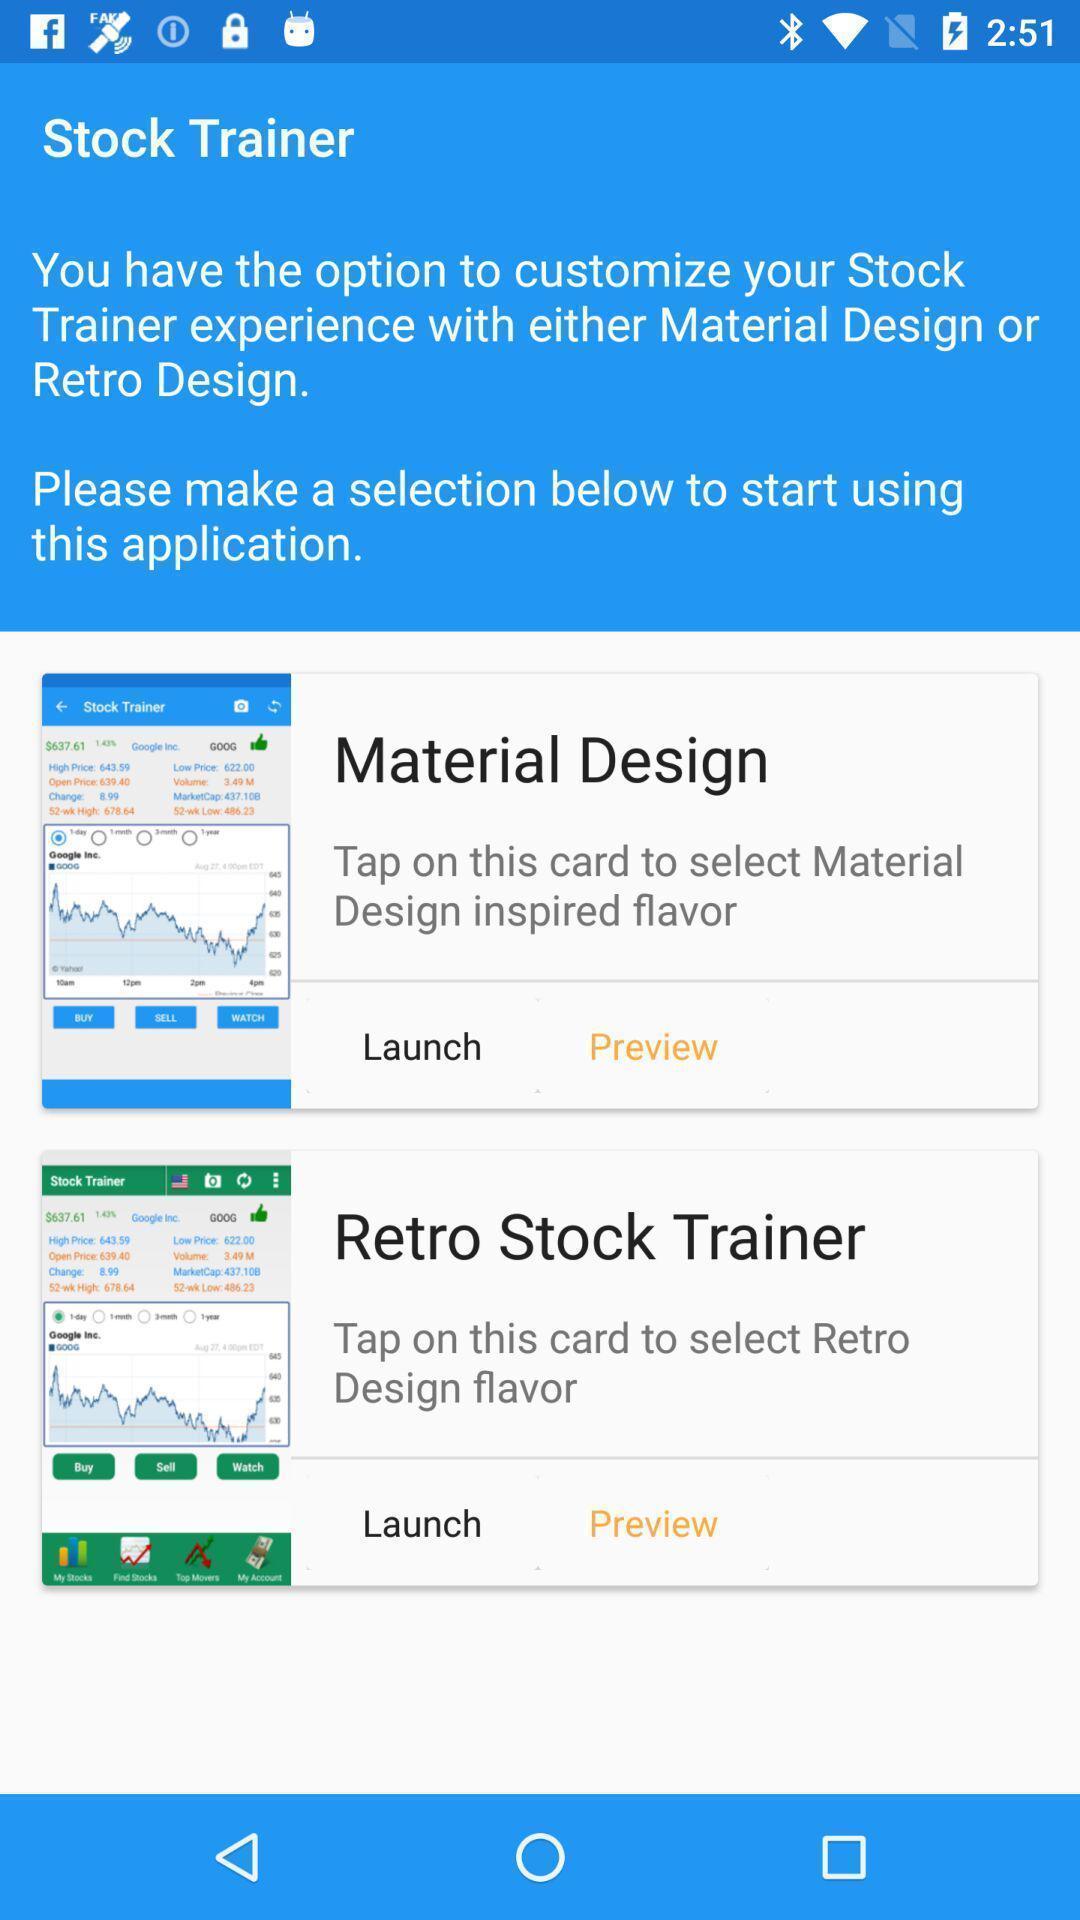Please provide a description for this image. Page showing the customize options for stock trainer. 